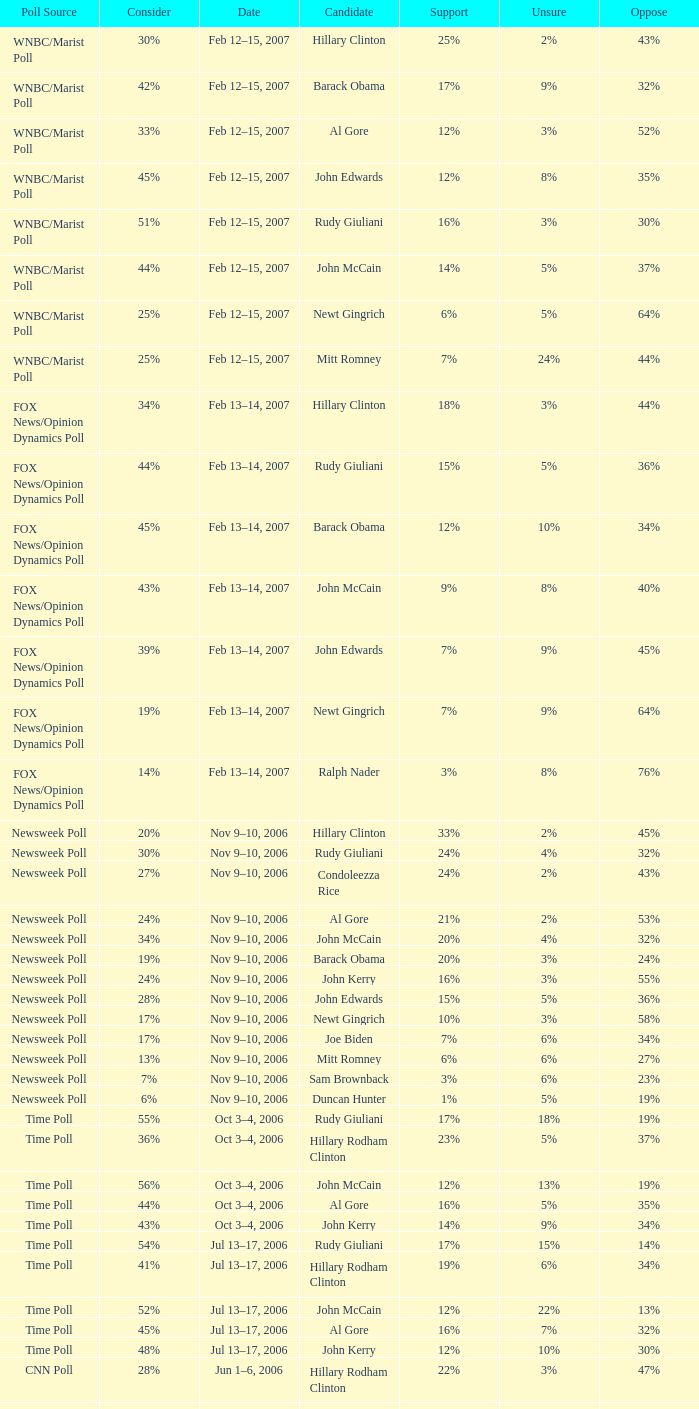What percentage of people were opposed to the candidate based on the Time Poll poll that showed 6% of people were unsure? 34%. 